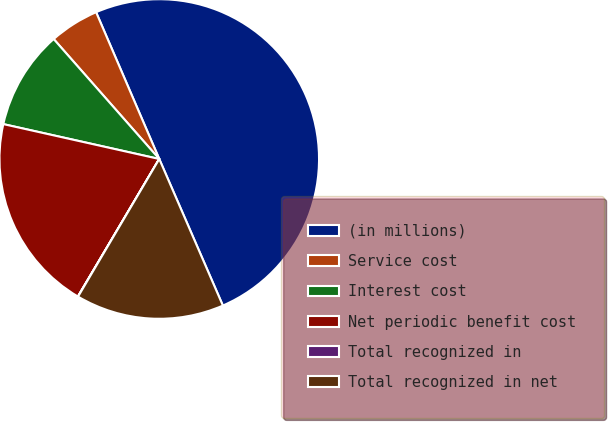<chart> <loc_0><loc_0><loc_500><loc_500><pie_chart><fcel>(in millions)<fcel>Service cost<fcel>Interest cost<fcel>Net periodic benefit cost<fcel>Total recognized in<fcel>Total recognized in net<nl><fcel>49.95%<fcel>5.02%<fcel>10.01%<fcel>20.0%<fcel>0.02%<fcel>15.0%<nl></chart> 